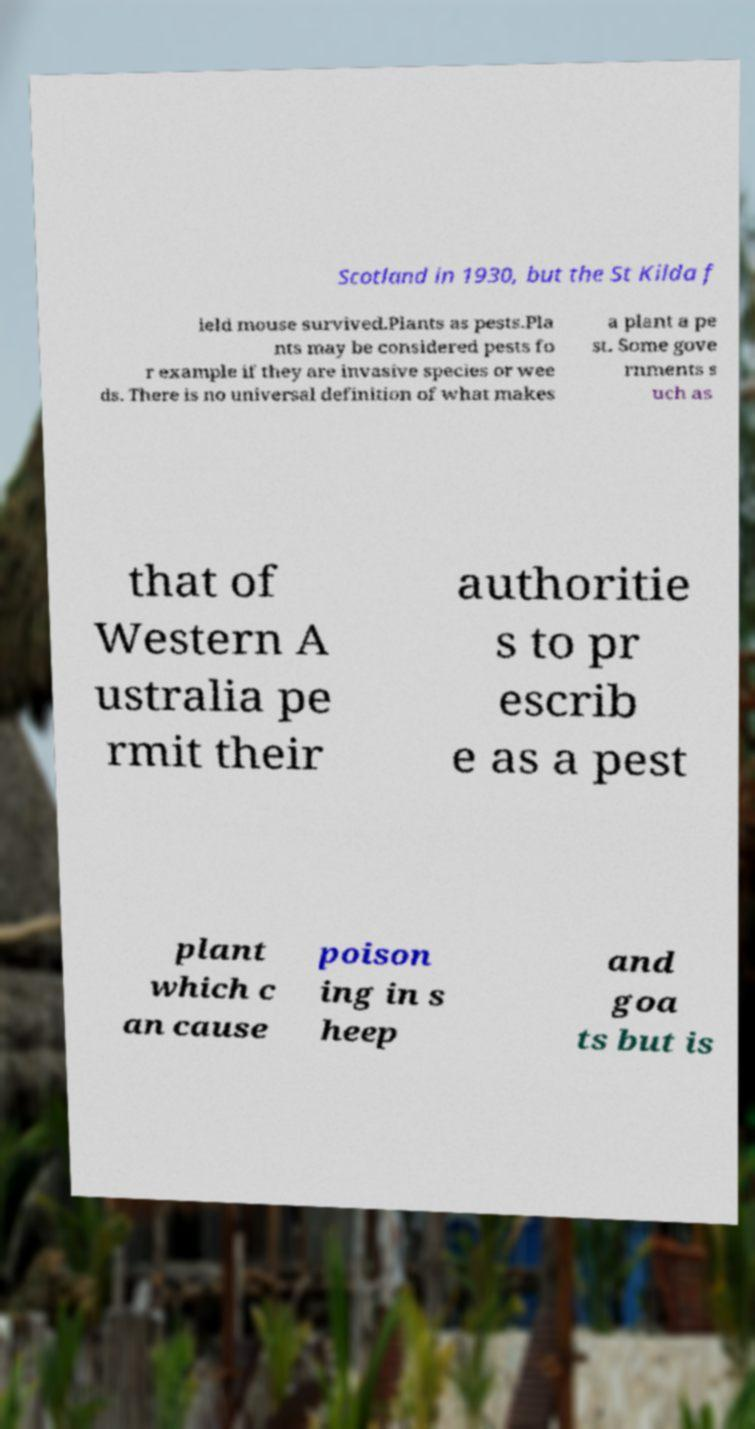I need the written content from this picture converted into text. Can you do that? Scotland in 1930, but the St Kilda f ield mouse survived.Plants as pests.Pla nts may be considered pests fo r example if they are invasive species or wee ds. There is no universal definition of what makes a plant a pe st. Some gove rnments s uch as that of Western A ustralia pe rmit their authoritie s to pr escrib e as a pest plant which c an cause poison ing in s heep and goa ts but is 